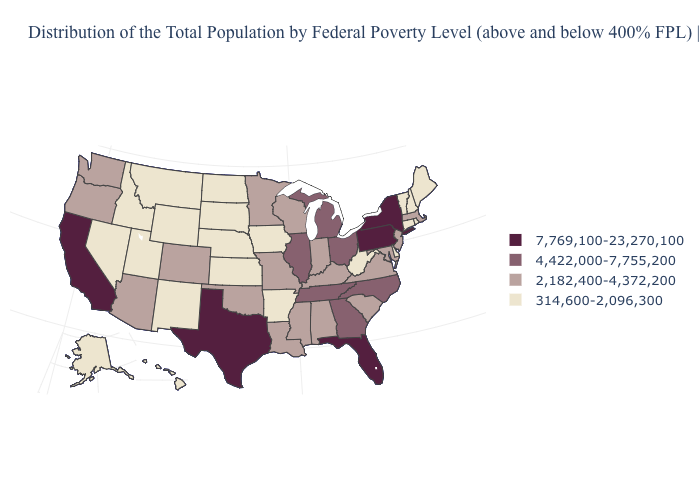Name the states that have a value in the range 314,600-2,096,300?
Quick response, please. Alaska, Arkansas, Connecticut, Delaware, Hawaii, Idaho, Iowa, Kansas, Maine, Montana, Nebraska, Nevada, New Hampshire, New Mexico, North Dakota, Rhode Island, South Dakota, Utah, Vermont, West Virginia, Wyoming. What is the value of Maine?
Answer briefly. 314,600-2,096,300. Name the states that have a value in the range 4,422,000-7,755,200?
Keep it brief. Georgia, Illinois, Michigan, North Carolina, Ohio, Tennessee. What is the lowest value in the USA?
Write a very short answer. 314,600-2,096,300. Name the states that have a value in the range 4,422,000-7,755,200?
Keep it brief. Georgia, Illinois, Michigan, North Carolina, Ohio, Tennessee. What is the value of New York?
Be succinct. 7,769,100-23,270,100. What is the lowest value in the USA?
Concise answer only. 314,600-2,096,300. What is the highest value in the USA?
Short answer required. 7,769,100-23,270,100. Is the legend a continuous bar?
Be succinct. No. What is the highest value in states that border Michigan?
Concise answer only. 4,422,000-7,755,200. Among the states that border Connecticut , does New York have the highest value?
Give a very brief answer. Yes. Which states have the lowest value in the USA?
Answer briefly. Alaska, Arkansas, Connecticut, Delaware, Hawaii, Idaho, Iowa, Kansas, Maine, Montana, Nebraska, Nevada, New Hampshire, New Mexico, North Dakota, Rhode Island, South Dakota, Utah, Vermont, West Virginia, Wyoming. What is the highest value in the USA?
Give a very brief answer. 7,769,100-23,270,100. Among the states that border Missouri , does Kentucky have the lowest value?
Be succinct. No. Which states hav the highest value in the West?
Short answer required. California. 